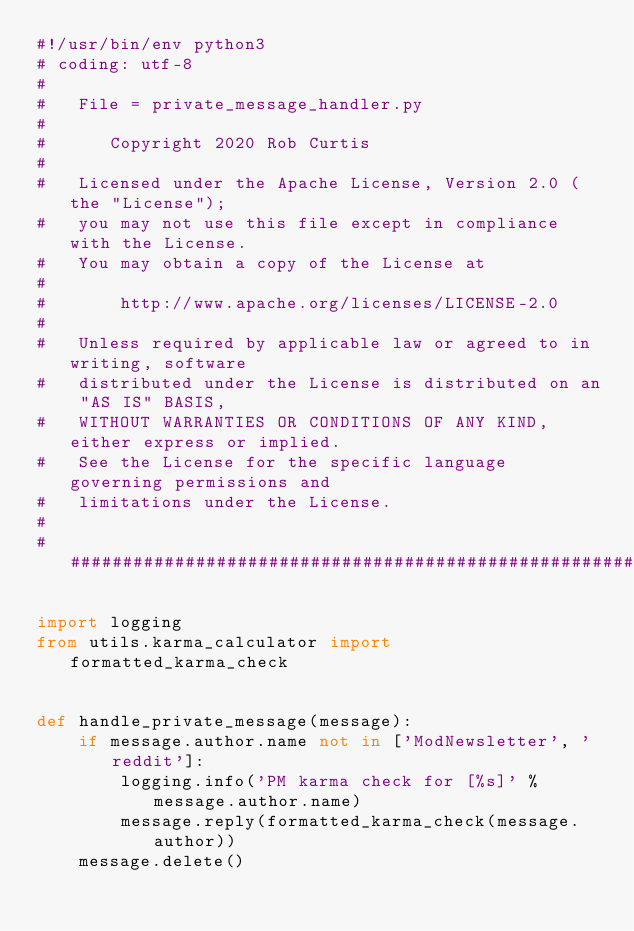Convert code to text. <code><loc_0><loc_0><loc_500><loc_500><_Python_>#!/usr/bin/env python3
# coding: utf-8
#
#   File = private_message_handler.py
#
#      Copyright 2020 Rob Curtis
#
#   Licensed under the Apache License, Version 2.0 (the "License");
#   you may not use this file except in compliance with the License.
#   You may obtain a copy of the License at
#
#       http://www.apache.org/licenses/LICENSE-2.0
#
#   Unless required by applicable law or agreed to in writing, software
#   distributed under the License is distributed on an "AS IS" BASIS,
#   WITHOUT WARRANTIES OR CONDITIONS OF ANY KIND, either express or implied.
#   See the License for the specific language governing permissions and
#   limitations under the License.
#
############################################################################

import logging
from utils.karma_calculator import formatted_karma_check


def handle_private_message(message):
    if message.author.name not in ['ModNewsletter', 'reddit']:
        logging.info('PM karma check for [%s]' % message.author.name)
        message.reply(formatted_karma_check(message.author))
    message.delete()
</code> 